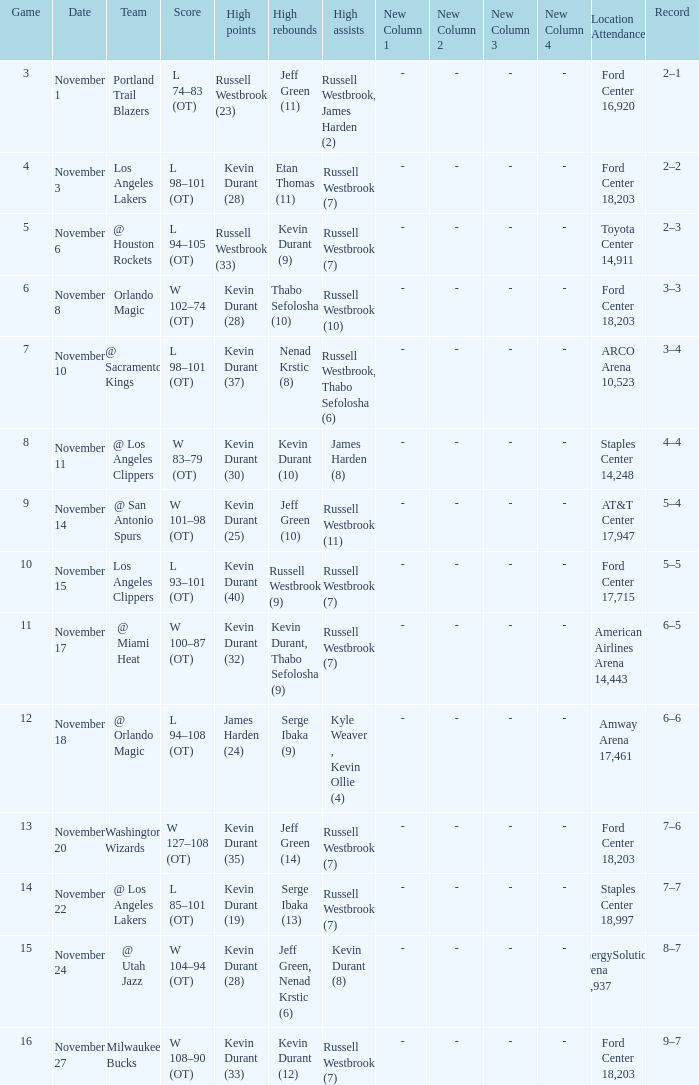Where was the game in which Kevin Durant (25) did the most high points played? AT&T Center 17,947. 